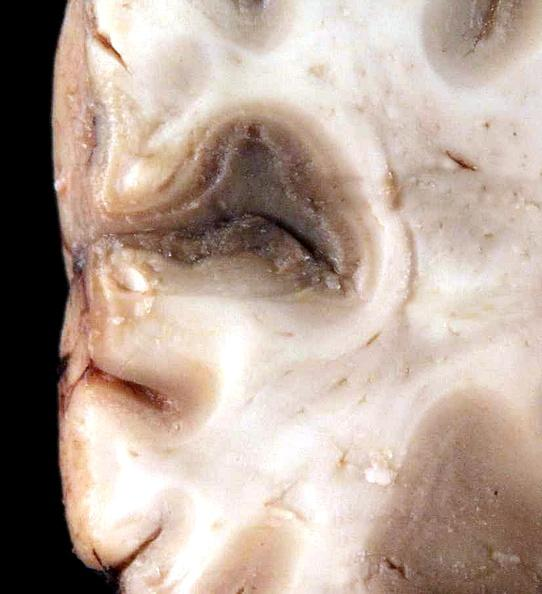does this image show brain, cryptococcal meningitis?
Answer the question using a single word or phrase. Yes 